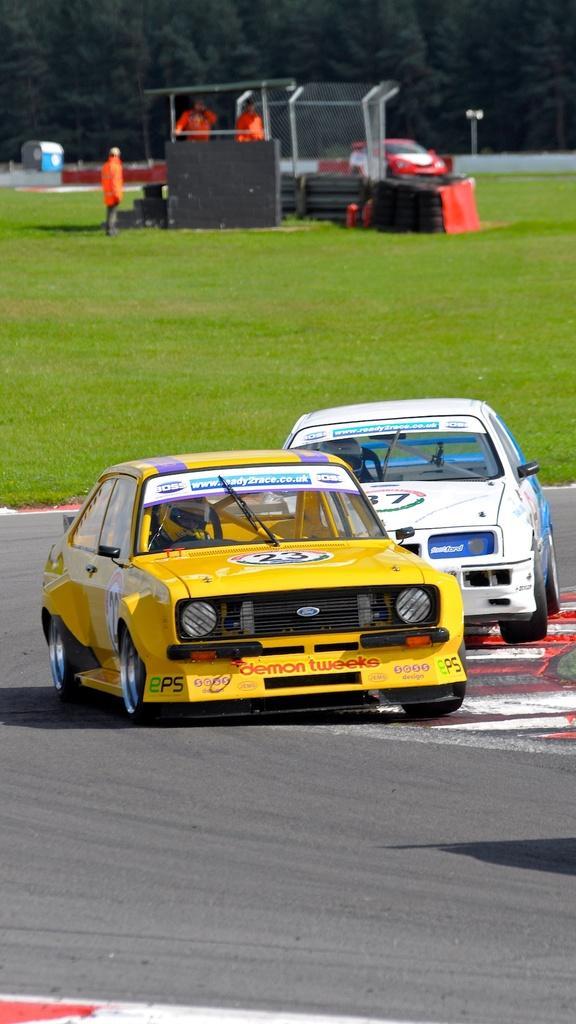In one or two sentences, can you explain what this image depicts? In this picture I can see three vehicles, there is grass, there are three persons standing, there are tyres and some other items, and in the background there are trees. 